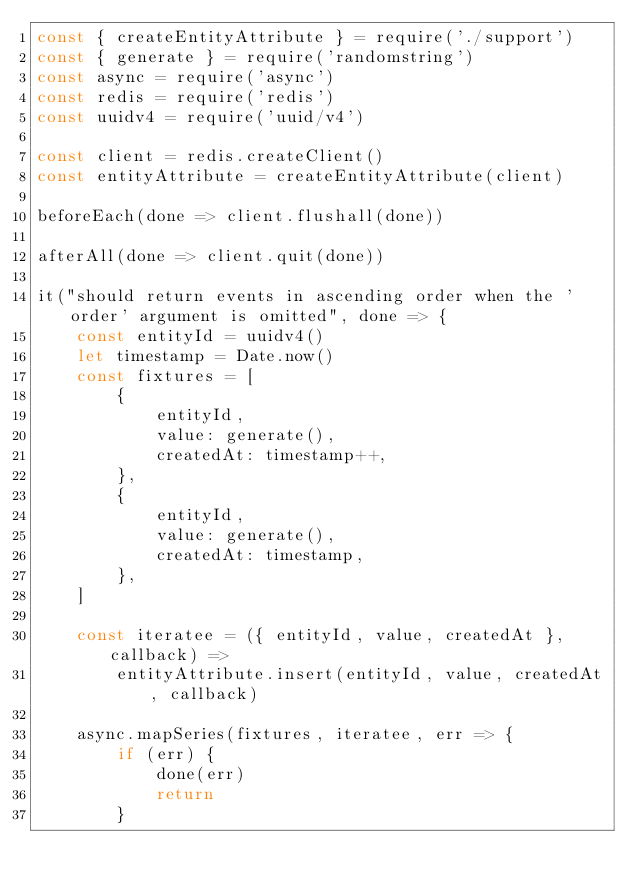Convert code to text. <code><loc_0><loc_0><loc_500><loc_500><_JavaScript_>const { createEntityAttribute } = require('./support')
const { generate } = require('randomstring')
const async = require('async')
const redis = require('redis')
const uuidv4 = require('uuid/v4')

const client = redis.createClient()
const entityAttribute = createEntityAttribute(client)

beforeEach(done => client.flushall(done))

afterAll(done => client.quit(done))

it("should return events in ascending order when the 'order' argument is omitted", done => {
    const entityId = uuidv4()
    let timestamp = Date.now()
    const fixtures = [
        {
            entityId,
            value: generate(),
            createdAt: timestamp++,
        },
        {
            entityId,
            value: generate(),
            createdAt: timestamp,
        },
    ]

    const iteratee = ({ entityId, value, createdAt }, callback) =>
        entityAttribute.insert(entityId, value, createdAt, callback)

    async.mapSeries(fixtures, iteratee, err => {
        if (err) {
            done(err)
            return
        }
</code> 